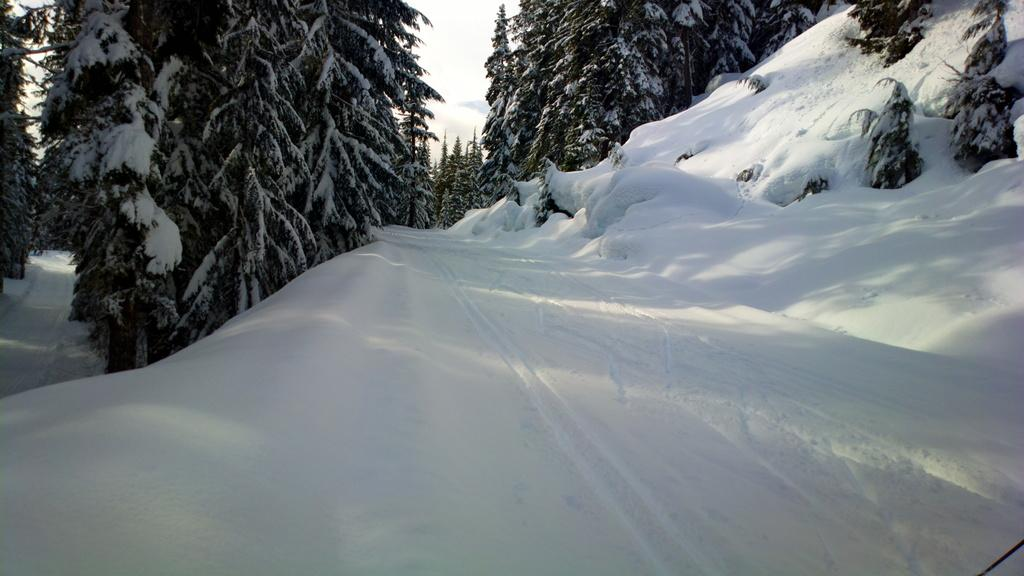What type of vegetation is visible in the image? There are trees in the image. What is covering the trees in the image? The trees are covered with snow. What is the condition of the ground in the image? There is snow on the ground. What is visible in the sky in the image? The sky is visible in the image. What can be seen in the sky in the image? There are clouds in the sky. What type of sail can be seen in the image? There is no sail present in the image. How many clocks are visible in the image? There are no clocks present in the image. 